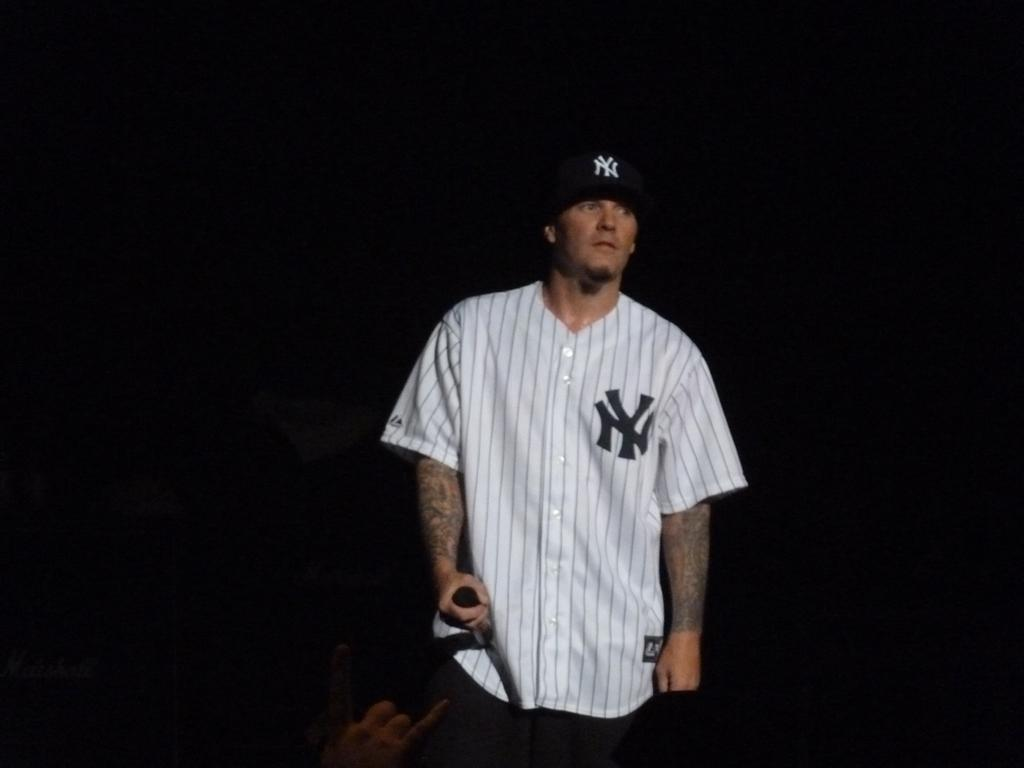<image>
Create a compact narrative representing the image presented. A man wearing a NY baseball kit is looking into the distance. 